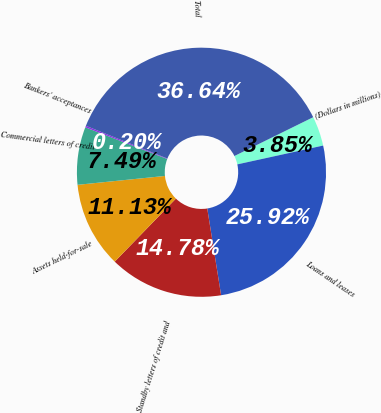<chart> <loc_0><loc_0><loc_500><loc_500><pie_chart><fcel>(Dollars in millions)<fcel>Loans and leases<fcel>Standby letters of credit and<fcel>Assets held-for-sale<fcel>Commercial letters of credit<fcel>Bankers' acceptances<fcel>Total<nl><fcel>3.85%<fcel>25.92%<fcel>14.78%<fcel>11.13%<fcel>7.49%<fcel>0.2%<fcel>36.64%<nl></chart> 